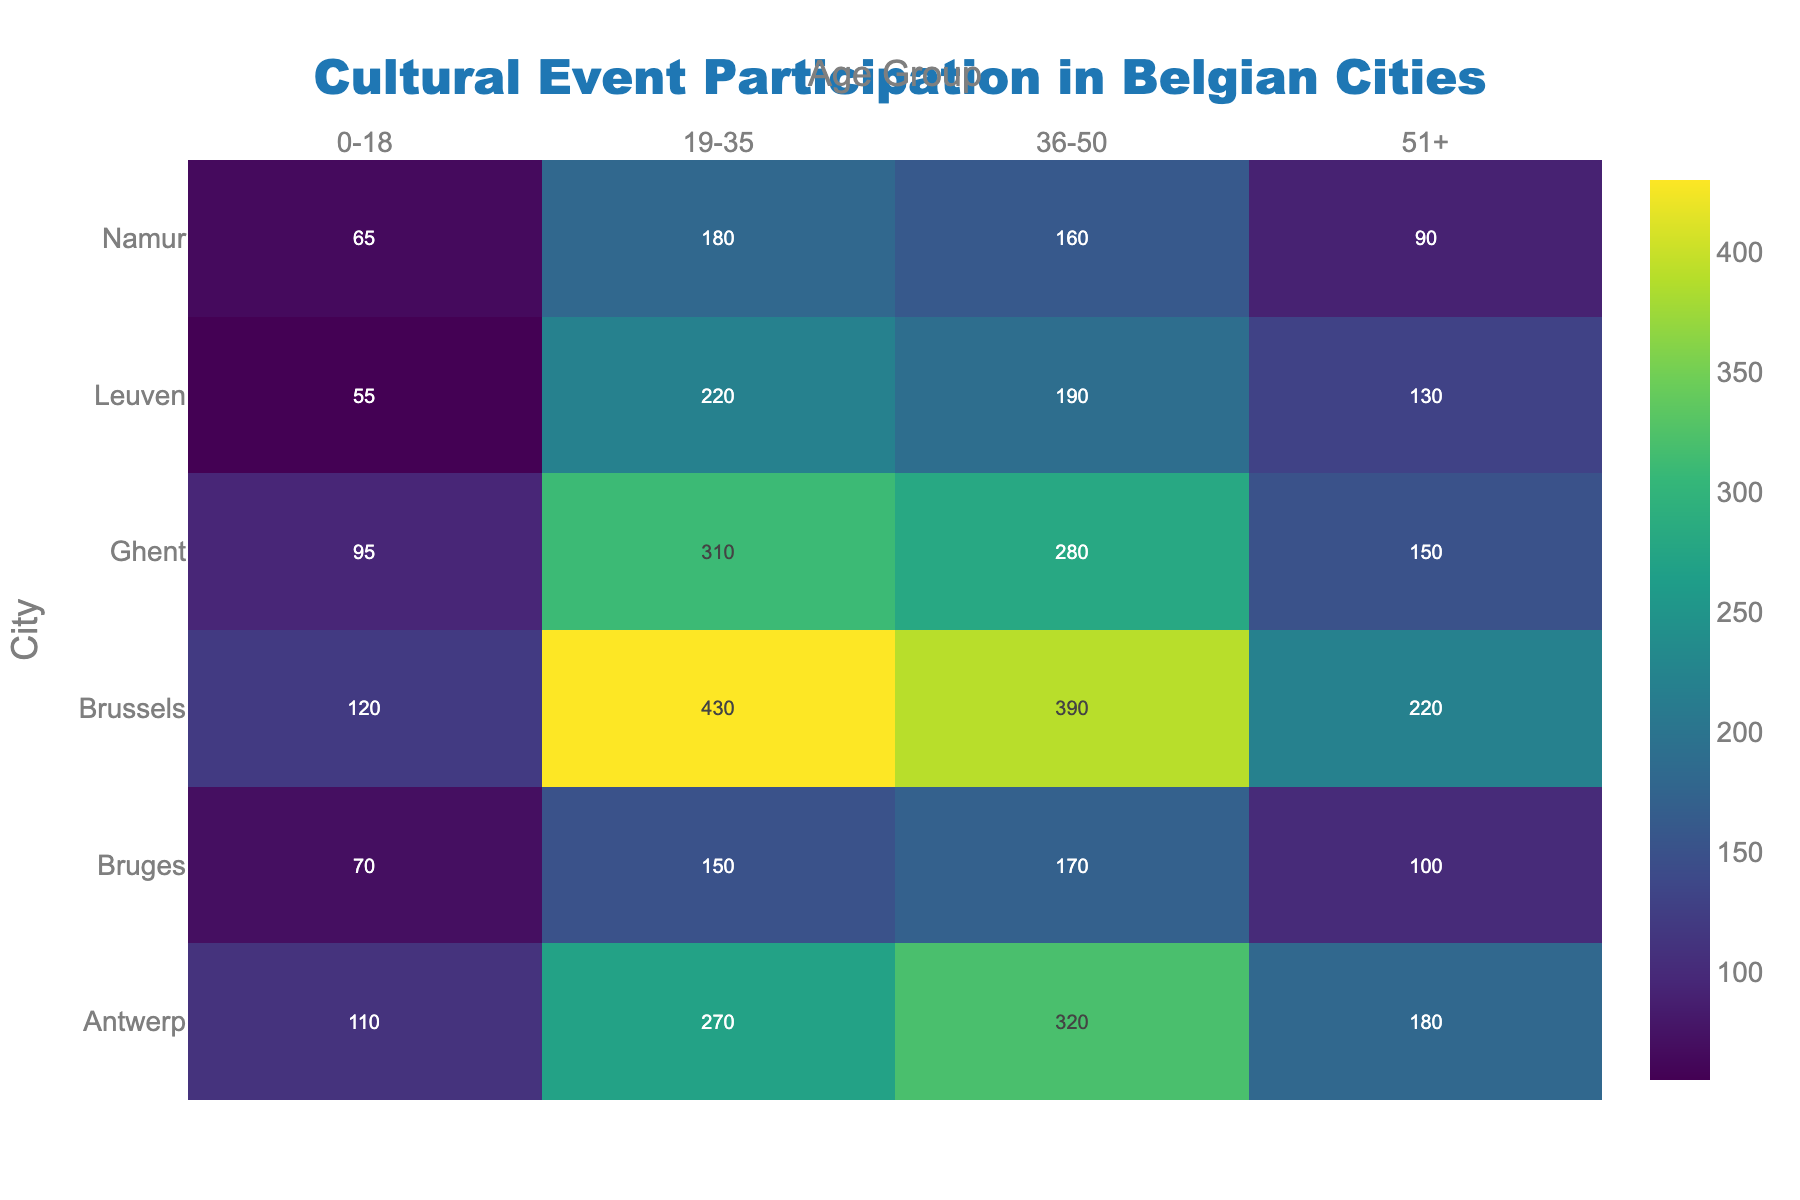Which city has the highest participation in the 19-35 age group? To determine the city with the highest participation in the 19-35 age group, look at the value corresponding to each city under the 19-35 column in the heatmap. The highest value is 430 for Brussels.
Answer: Brussels Which city has the lowest participation in the 0-18 age group? To find the city with the lowest participation in the 0-18 age group, check the values under the 0-18 column. The lowest value is 55, which corresponds to Leuven.
Answer: Leuven What is the total participation for the city of Bruges across all age groups? Sum the participation values for Bruges across all age groups: 70 (0-18) + 150 (19-35) + 170 (36-50) + 100 (51+). The total is 70 + 150 + 170 + 100 = 490.
Answer: 490 Between Ghent and Namur, which city has more participation in the 51+ age group? Compare the values for Ghent and Namur in the 51+ age group. Ghent has a value of 150, while Namur has a value of 90. Thus, Ghent has more participation.
Answer: Ghent How does the participation of the 36-50 age group in Antwerp compare to that in Brussels? Look at the values for Antwerp and Brussels in the 36-50 age group. Antwerp has a participation value of 320, whereas Brussels has 390. Brussels has higher participation by a difference of 390 - 320 = 70.
Answer: Brussels has 70 more participants What's the average participation value for the 0-18 age group across all cities? Sum the participation values for the 0-18 age group and divide by the number of cities: (120 + 110 + 95 + 70 + 55 + 65). The sum is 515, and with 6 cities, the average is 515 / 6 = 85.83.
Answer: 85.83 Is there any age group where Leuven has the highest participation among all cities? For each age group, check if Leuven has the highest value. None of the age groups (0-18, 19-35, 36-50, 51+) have Leuven with the highest participation compared to other cities.
Answer: No What is the difference in total participation between Brussels and Antwerp? Sum the total participation values for Brussels and Antwerp. Brussels: 120 + 430 + 390 + 220 = 1160. Antwerp: 110 + 270 + 320 + 180 = 880. The difference is 1160 - 880 = 280.
Answer: 280 Which age group has the most variation in participation numbers across all cities? Calculate the range (max-min) for each age group. 
0-18: range = 120 - 55 = 65
19-35: range = 430 - 150 = 280
36-50: range = 390 - 160 = 230
51+: range = 220 - 90 = 130
The highest range is in the 19-35 age group with 280.
Answer: 19-35 Which two age groups have the closest participation in Ghent? Compare participation values in Ghent for the four age groups:
0-18: 95
19-35: 310
36-50: 280
51+: 150
The closest values are 280 (36-50) and 310 (19-35), with a difference of 30.
Answer: 19-35 and 36-50 